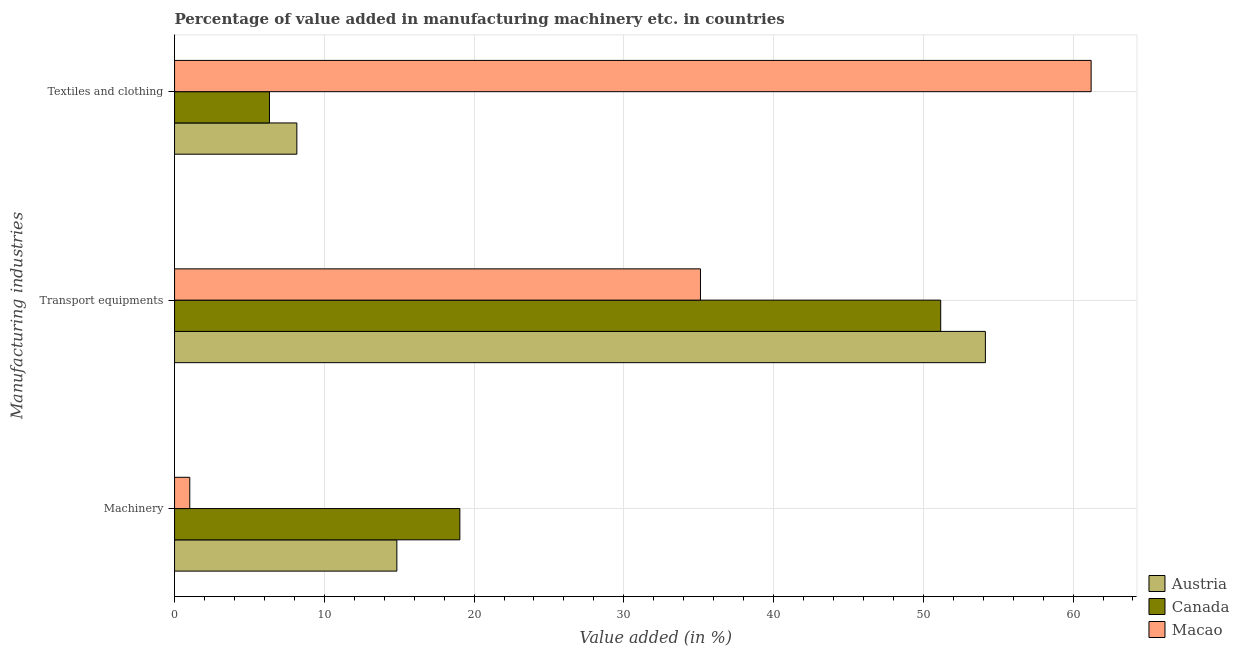How many different coloured bars are there?
Provide a succinct answer. 3. How many groups of bars are there?
Offer a very short reply. 3. Are the number of bars on each tick of the Y-axis equal?
Your answer should be compact. Yes. How many bars are there on the 3rd tick from the top?
Offer a terse response. 3. How many bars are there on the 3rd tick from the bottom?
Make the answer very short. 3. What is the label of the 3rd group of bars from the top?
Give a very brief answer. Machinery. What is the value added in manufacturing transport equipments in Austria?
Offer a terse response. 54.14. Across all countries, what is the maximum value added in manufacturing textile and clothing?
Keep it short and to the point. 61.21. Across all countries, what is the minimum value added in manufacturing transport equipments?
Provide a succinct answer. 35.12. In which country was the value added in manufacturing textile and clothing maximum?
Offer a terse response. Macao. In which country was the value added in manufacturing transport equipments minimum?
Your response must be concise. Macao. What is the total value added in manufacturing textile and clothing in the graph?
Your response must be concise. 75.71. What is the difference between the value added in manufacturing transport equipments in Austria and that in Macao?
Your answer should be very brief. 19.03. What is the difference between the value added in manufacturing textile and clothing in Canada and the value added in manufacturing transport equipments in Austria?
Keep it short and to the point. -47.81. What is the average value added in manufacturing textile and clothing per country?
Your answer should be compact. 25.24. What is the difference between the value added in manufacturing machinery and value added in manufacturing textile and clothing in Canada?
Your response must be concise. 12.71. What is the ratio of the value added in manufacturing machinery in Austria to that in Macao?
Give a very brief answer. 14.6. What is the difference between the highest and the second highest value added in manufacturing textile and clothing?
Keep it short and to the point. 53.04. What is the difference between the highest and the lowest value added in manufacturing textile and clothing?
Your answer should be compact. 54.87. In how many countries, is the value added in manufacturing machinery greater than the average value added in manufacturing machinery taken over all countries?
Make the answer very short. 2. What does the 3rd bar from the bottom in Transport equipments represents?
Give a very brief answer. Macao. How many countries are there in the graph?
Your answer should be very brief. 3. What is the difference between two consecutive major ticks on the X-axis?
Give a very brief answer. 10. How are the legend labels stacked?
Keep it short and to the point. Vertical. What is the title of the graph?
Offer a very short reply. Percentage of value added in manufacturing machinery etc. in countries. What is the label or title of the X-axis?
Make the answer very short. Value added (in %). What is the label or title of the Y-axis?
Keep it short and to the point. Manufacturing industries. What is the Value added (in %) of Austria in Machinery?
Provide a short and direct response. 14.84. What is the Value added (in %) of Canada in Machinery?
Your answer should be compact. 19.05. What is the Value added (in %) in Macao in Machinery?
Your answer should be compact. 1.02. What is the Value added (in %) of Austria in Transport equipments?
Provide a succinct answer. 54.14. What is the Value added (in %) in Canada in Transport equipments?
Provide a short and direct response. 51.16. What is the Value added (in %) in Macao in Transport equipments?
Ensure brevity in your answer.  35.12. What is the Value added (in %) in Austria in Textiles and clothing?
Provide a succinct answer. 8.17. What is the Value added (in %) of Canada in Textiles and clothing?
Give a very brief answer. 6.34. What is the Value added (in %) of Macao in Textiles and clothing?
Your response must be concise. 61.21. Across all Manufacturing industries, what is the maximum Value added (in %) in Austria?
Offer a terse response. 54.14. Across all Manufacturing industries, what is the maximum Value added (in %) of Canada?
Your response must be concise. 51.16. Across all Manufacturing industries, what is the maximum Value added (in %) of Macao?
Your answer should be very brief. 61.21. Across all Manufacturing industries, what is the minimum Value added (in %) in Austria?
Provide a succinct answer. 8.17. Across all Manufacturing industries, what is the minimum Value added (in %) in Canada?
Your answer should be very brief. 6.34. Across all Manufacturing industries, what is the minimum Value added (in %) of Macao?
Your response must be concise. 1.02. What is the total Value added (in %) in Austria in the graph?
Your answer should be compact. 77.16. What is the total Value added (in %) in Canada in the graph?
Your answer should be compact. 76.55. What is the total Value added (in %) of Macao in the graph?
Keep it short and to the point. 97.34. What is the difference between the Value added (in %) of Austria in Machinery and that in Transport equipments?
Ensure brevity in your answer.  -39.3. What is the difference between the Value added (in %) in Canada in Machinery and that in Transport equipments?
Ensure brevity in your answer.  -32.11. What is the difference between the Value added (in %) of Macao in Machinery and that in Transport equipments?
Provide a succinct answer. -34.1. What is the difference between the Value added (in %) of Austria in Machinery and that in Textiles and clothing?
Your answer should be compact. 6.68. What is the difference between the Value added (in %) of Canada in Machinery and that in Textiles and clothing?
Your answer should be compact. 12.71. What is the difference between the Value added (in %) of Macao in Machinery and that in Textiles and clothing?
Offer a very short reply. -60.19. What is the difference between the Value added (in %) of Austria in Transport equipments and that in Textiles and clothing?
Make the answer very short. 45.98. What is the difference between the Value added (in %) of Canada in Transport equipments and that in Textiles and clothing?
Keep it short and to the point. 44.82. What is the difference between the Value added (in %) in Macao in Transport equipments and that in Textiles and clothing?
Make the answer very short. -26.09. What is the difference between the Value added (in %) of Austria in Machinery and the Value added (in %) of Canada in Transport equipments?
Your answer should be compact. -36.32. What is the difference between the Value added (in %) in Austria in Machinery and the Value added (in %) in Macao in Transport equipments?
Your answer should be compact. -20.27. What is the difference between the Value added (in %) of Canada in Machinery and the Value added (in %) of Macao in Transport equipments?
Offer a terse response. -16.07. What is the difference between the Value added (in %) of Austria in Machinery and the Value added (in %) of Canada in Textiles and clothing?
Your answer should be compact. 8.51. What is the difference between the Value added (in %) in Austria in Machinery and the Value added (in %) in Macao in Textiles and clothing?
Offer a terse response. -46.36. What is the difference between the Value added (in %) of Canada in Machinery and the Value added (in %) of Macao in Textiles and clothing?
Make the answer very short. -42.15. What is the difference between the Value added (in %) in Austria in Transport equipments and the Value added (in %) in Canada in Textiles and clothing?
Your response must be concise. 47.81. What is the difference between the Value added (in %) of Austria in Transport equipments and the Value added (in %) of Macao in Textiles and clothing?
Your answer should be very brief. -7.06. What is the difference between the Value added (in %) of Canada in Transport equipments and the Value added (in %) of Macao in Textiles and clothing?
Provide a succinct answer. -10.04. What is the average Value added (in %) in Austria per Manufacturing industries?
Your response must be concise. 25.72. What is the average Value added (in %) of Canada per Manufacturing industries?
Your response must be concise. 25.52. What is the average Value added (in %) of Macao per Manufacturing industries?
Keep it short and to the point. 32.45. What is the difference between the Value added (in %) in Austria and Value added (in %) in Canada in Machinery?
Keep it short and to the point. -4.21. What is the difference between the Value added (in %) of Austria and Value added (in %) of Macao in Machinery?
Make the answer very short. 13.83. What is the difference between the Value added (in %) of Canada and Value added (in %) of Macao in Machinery?
Give a very brief answer. 18.04. What is the difference between the Value added (in %) of Austria and Value added (in %) of Canada in Transport equipments?
Offer a terse response. 2.98. What is the difference between the Value added (in %) of Austria and Value added (in %) of Macao in Transport equipments?
Make the answer very short. 19.03. What is the difference between the Value added (in %) of Canada and Value added (in %) of Macao in Transport equipments?
Make the answer very short. 16.04. What is the difference between the Value added (in %) in Austria and Value added (in %) in Canada in Textiles and clothing?
Give a very brief answer. 1.83. What is the difference between the Value added (in %) of Austria and Value added (in %) of Macao in Textiles and clothing?
Your response must be concise. -53.04. What is the difference between the Value added (in %) of Canada and Value added (in %) of Macao in Textiles and clothing?
Offer a very short reply. -54.87. What is the ratio of the Value added (in %) in Austria in Machinery to that in Transport equipments?
Offer a very short reply. 0.27. What is the ratio of the Value added (in %) of Canada in Machinery to that in Transport equipments?
Offer a terse response. 0.37. What is the ratio of the Value added (in %) of Macao in Machinery to that in Transport equipments?
Provide a succinct answer. 0.03. What is the ratio of the Value added (in %) in Austria in Machinery to that in Textiles and clothing?
Offer a terse response. 1.82. What is the ratio of the Value added (in %) in Canada in Machinery to that in Textiles and clothing?
Give a very brief answer. 3.01. What is the ratio of the Value added (in %) in Macao in Machinery to that in Textiles and clothing?
Ensure brevity in your answer.  0.02. What is the ratio of the Value added (in %) in Austria in Transport equipments to that in Textiles and clothing?
Ensure brevity in your answer.  6.63. What is the ratio of the Value added (in %) in Canada in Transport equipments to that in Textiles and clothing?
Ensure brevity in your answer.  8.07. What is the ratio of the Value added (in %) of Macao in Transport equipments to that in Textiles and clothing?
Offer a very short reply. 0.57. What is the difference between the highest and the second highest Value added (in %) in Austria?
Ensure brevity in your answer.  39.3. What is the difference between the highest and the second highest Value added (in %) in Canada?
Give a very brief answer. 32.11. What is the difference between the highest and the second highest Value added (in %) in Macao?
Keep it short and to the point. 26.09. What is the difference between the highest and the lowest Value added (in %) of Austria?
Offer a terse response. 45.98. What is the difference between the highest and the lowest Value added (in %) in Canada?
Give a very brief answer. 44.82. What is the difference between the highest and the lowest Value added (in %) in Macao?
Offer a very short reply. 60.19. 